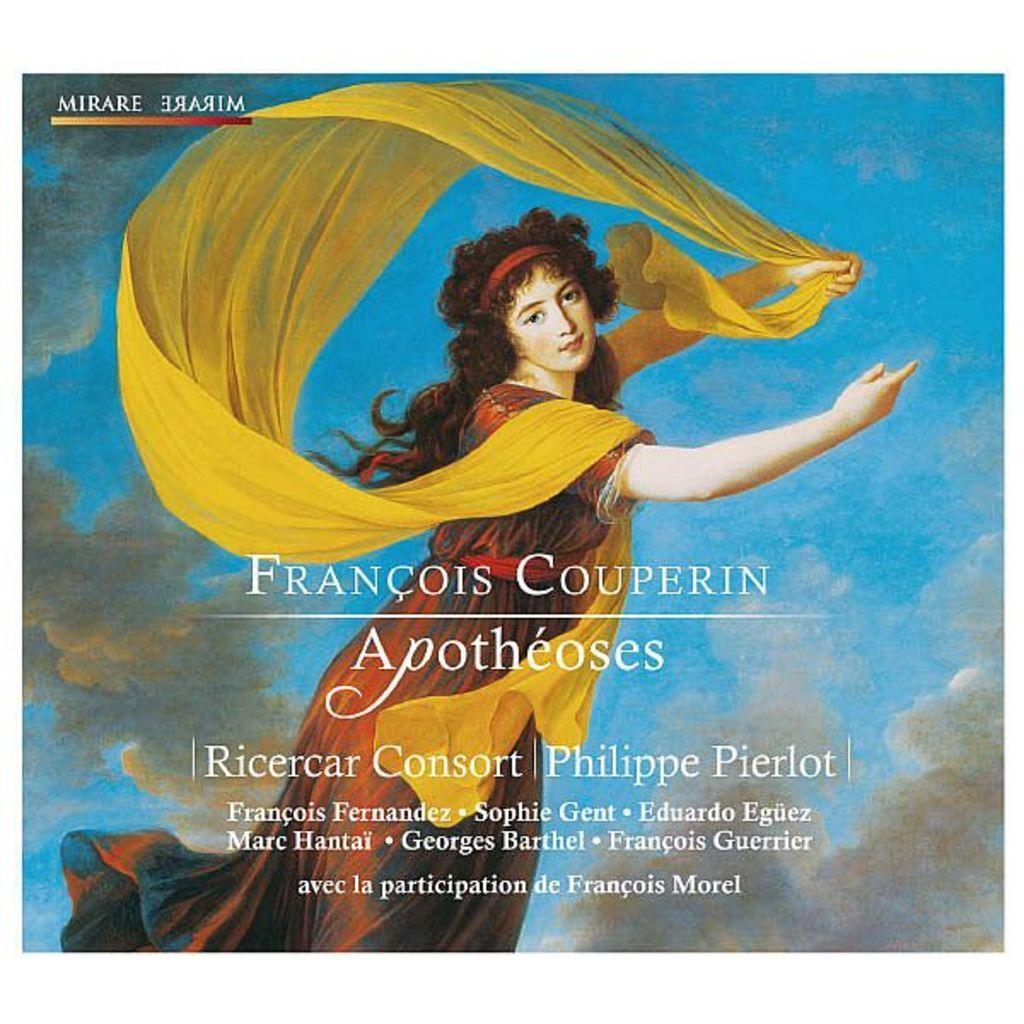<image>
Render a clear and concise summary of the photo. An album by Francois Couperin shows a woman with a yellow scarf on the front. 